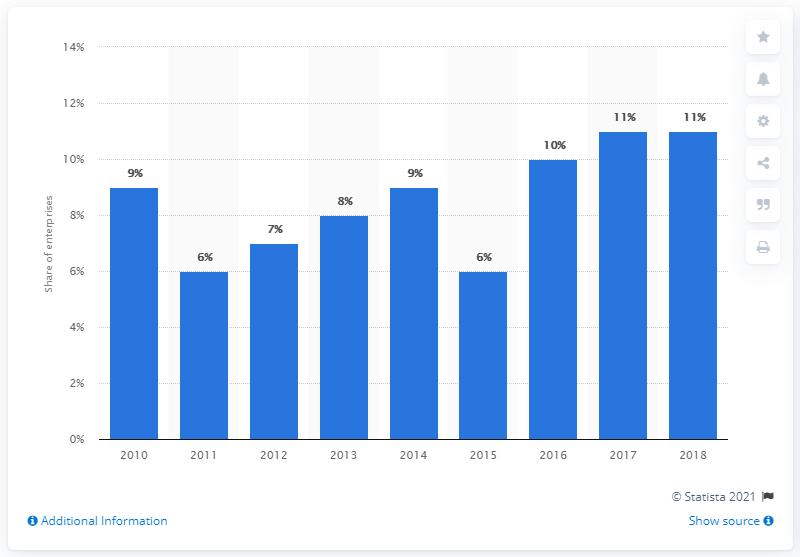List a handful of essential elements in this visual. In 2017, the share of companies selling online in Greece was measured at the same level as it is today. In 2018, the highest percentage of companies in Greece that sold online was 11%. 